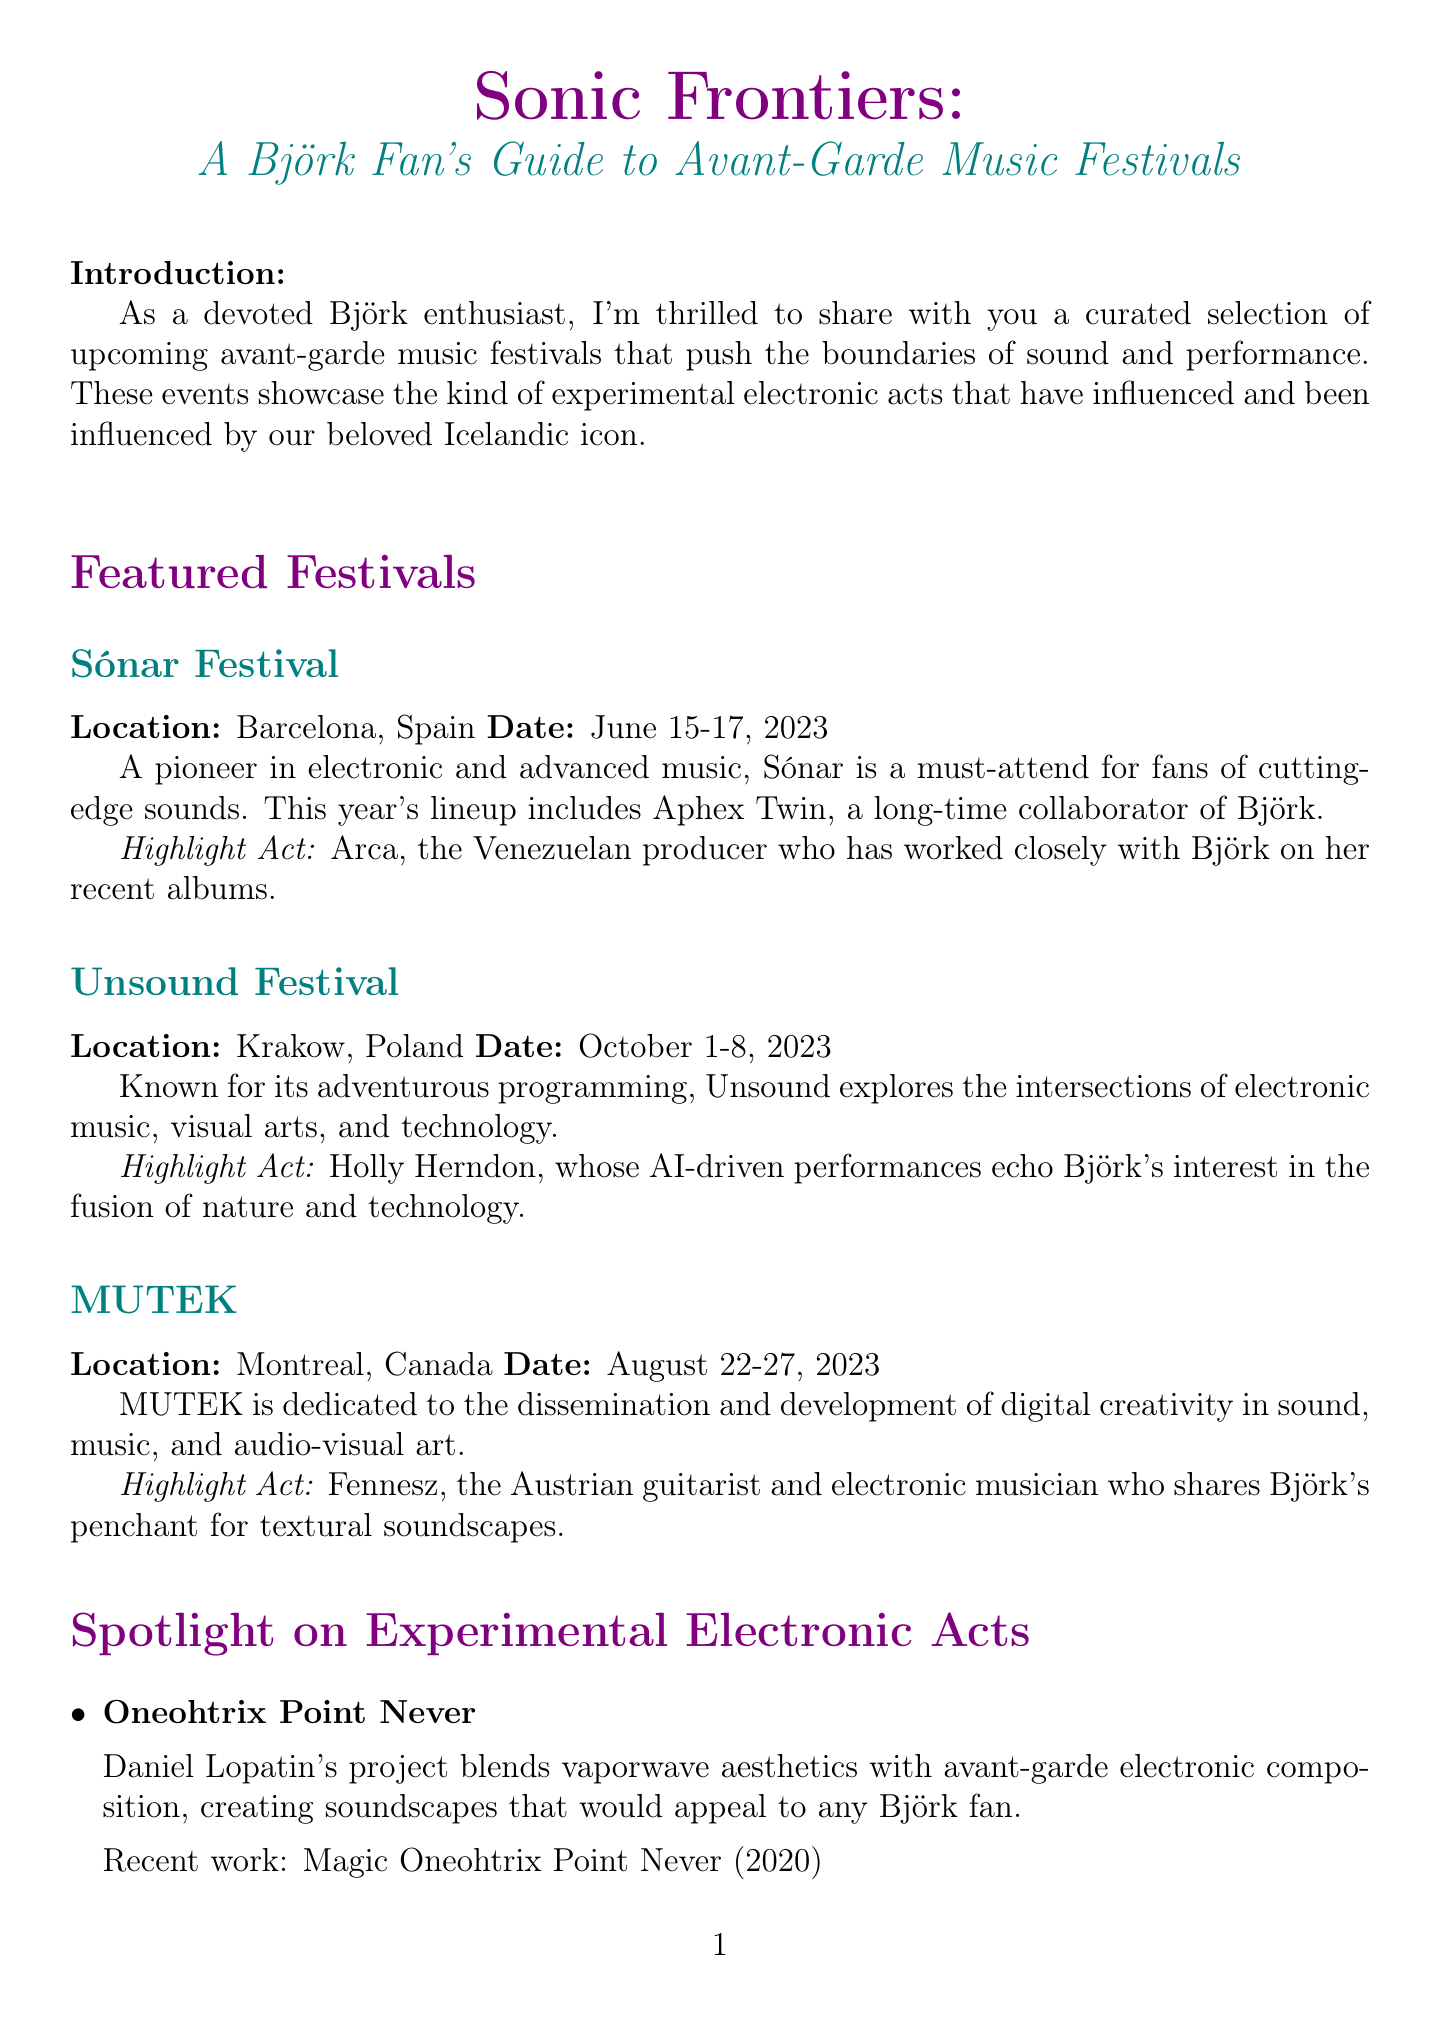What is the location of the Sónar Festival? The location of the Sónar Festival is specified in the document as Barcelona, Spain.
Answer: Barcelona, Spain When does the Unsound Festival take place? The date for the Unsound Festival is mentioned as October 1-8, 2023.
Answer: October 1-8, 2023 Who is the highlight act for the MUTEK festival? The document identifies Fennesz as the highlight act for the MUTEK festival.
Answer: Fennesz What recent work is associated with Eartheater? The recent work listed in the document for Eartheater is "Phoenix: Flames Are Dew Upon My Skin."
Answer: Phoenix: Flames Are Dew Upon My Skin How does Björk influence the avant-garde scene? The document explains that Björk's innovative approach inspires a new generation of experimental artists.
Answer: Innovative approach What type of music does MUTEK focus on? The document states that MUTEK is dedicated to digital creativity in sound, music, and audio-visual art.
Answer: Digital creativity Which artist's recent work is titled "Embryo EP"? The document indicates that Jlin's recent work is titled "Embryo EP."
Answer: Jlin What is the title of the newsletter? The title of the newsletter is provided at the beginning of the document as "Sonic Frontiers: A Björk Fan's Guide to Avant-Garde Music Festivals."
Answer: Sonic Frontiers: A Björk Fan's Guide to Avant-Garde Music Festivals 